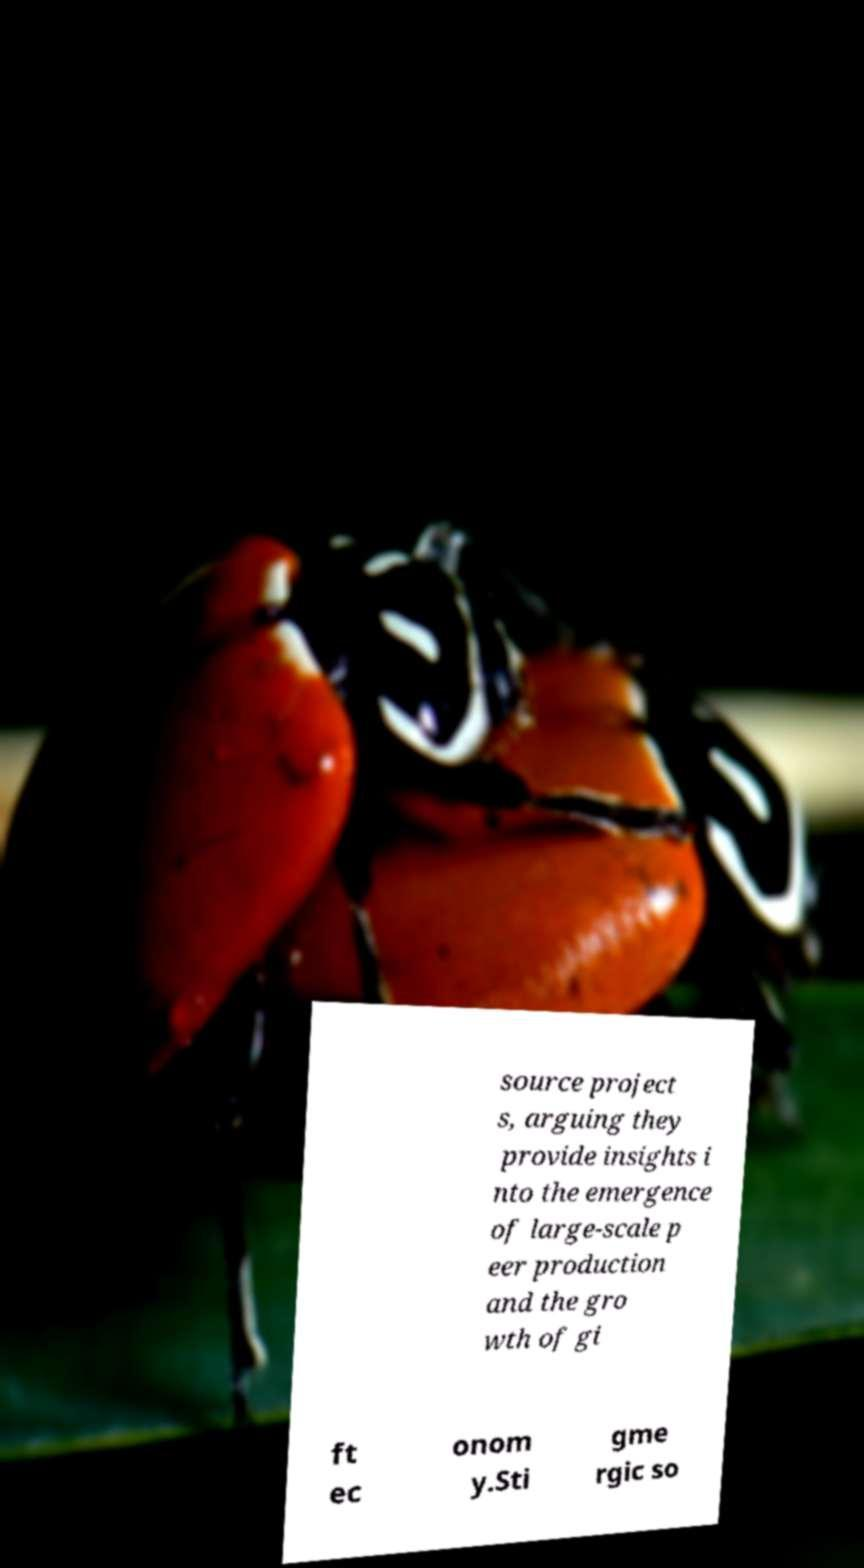For documentation purposes, I need the text within this image transcribed. Could you provide that? source project s, arguing they provide insights i nto the emergence of large-scale p eer production and the gro wth of gi ft ec onom y.Sti gme rgic so 